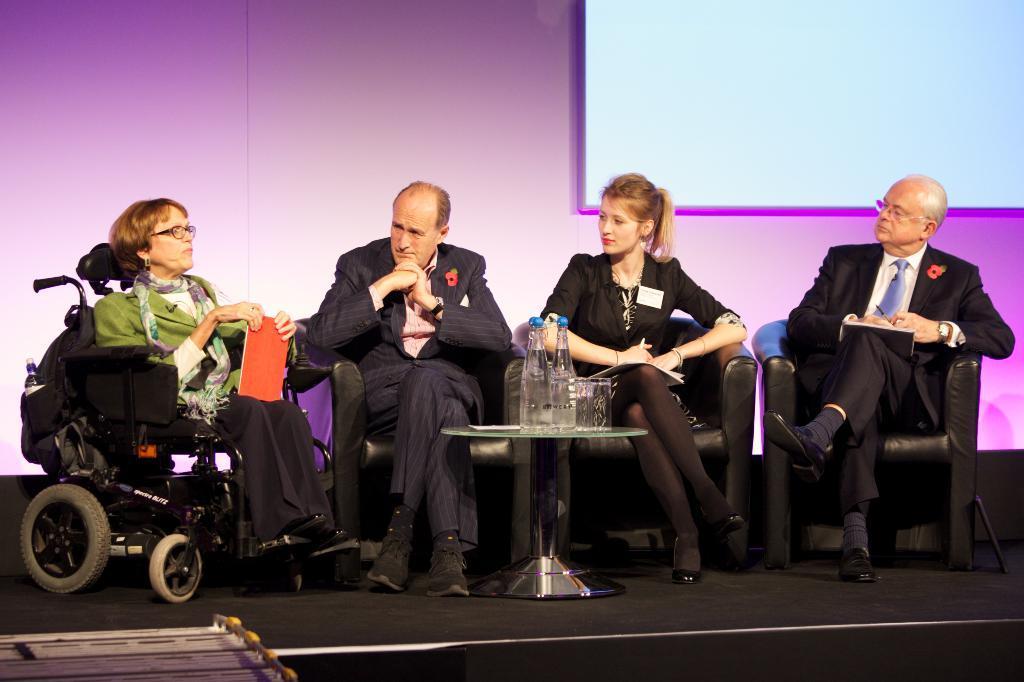Could you give a brief overview of what you see in this image? In this picture we can see three people sitting on the chair. We can see a woman holding a book and sitting on a wheel chair. There are few bottles and glasses on a round table. There is a whiteboard on the right side. 